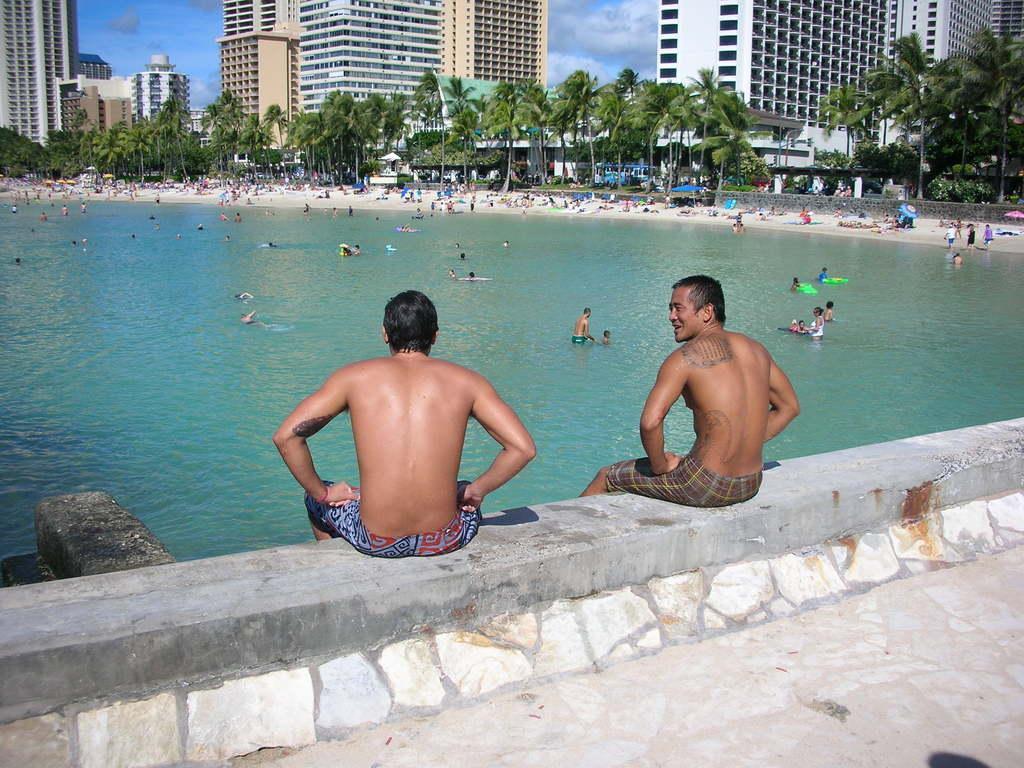Please provide a concise description of this image. There are two persons in shorts sitting on the wall. Beside this wall, there is water in which, there are persons. In the background, there are persons on the ground, there are trees, buildings and there are clouds in the blue sky. 